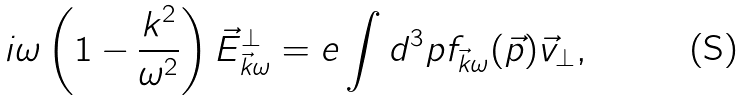<formula> <loc_0><loc_0><loc_500><loc_500>i \omega \left ( 1 - \frac { k ^ { 2 } } { \omega ^ { 2 } } \right ) \vec { E } _ { \vec { k } \omega } ^ { \perp } = e \int d ^ { 3 } p f _ { \vec { k } \omega } ( \vec { p } ) \vec { v } _ { \perp } ,</formula> 